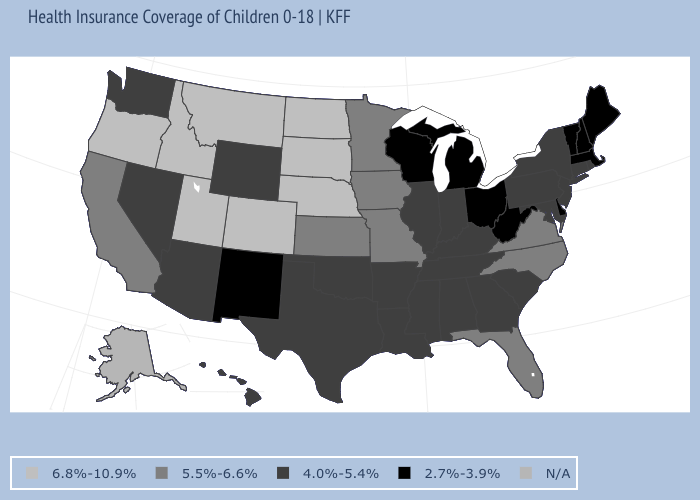Name the states that have a value in the range N/A?
Be succinct. Alaska. Does the first symbol in the legend represent the smallest category?
Concise answer only. No. Is the legend a continuous bar?
Answer briefly. No. What is the value of Oklahoma?
Give a very brief answer. 4.0%-5.4%. What is the value of Virginia?
Short answer required. 5.5%-6.6%. Name the states that have a value in the range 6.8%-10.9%?
Answer briefly. Colorado, Idaho, Montana, Nebraska, North Dakota, Oregon, South Dakota, Utah. What is the value of Louisiana?
Give a very brief answer. 4.0%-5.4%. Does Missouri have the highest value in the MidWest?
Write a very short answer. No. What is the value of Kansas?
Be succinct. 5.5%-6.6%. Does Massachusetts have the lowest value in the USA?
Keep it brief. Yes. Name the states that have a value in the range 6.8%-10.9%?
Keep it brief. Colorado, Idaho, Montana, Nebraska, North Dakota, Oregon, South Dakota, Utah. Name the states that have a value in the range 2.7%-3.9%?
Short answer required. Delaware, Maine, Massachusetts, Michigan, New Hampshire, New Mexico, Ohio, Vermont, West Virginia, Wisconsin. Which states hav the highest value in the MidWest?
Be succinct. Nebraska, North Dakota, South Dakota. Does Alabama have the lowest value in the South?
Concise answer only. No. What is the value of Utah?
Write a very short answer. 6.8%-10.9%. 